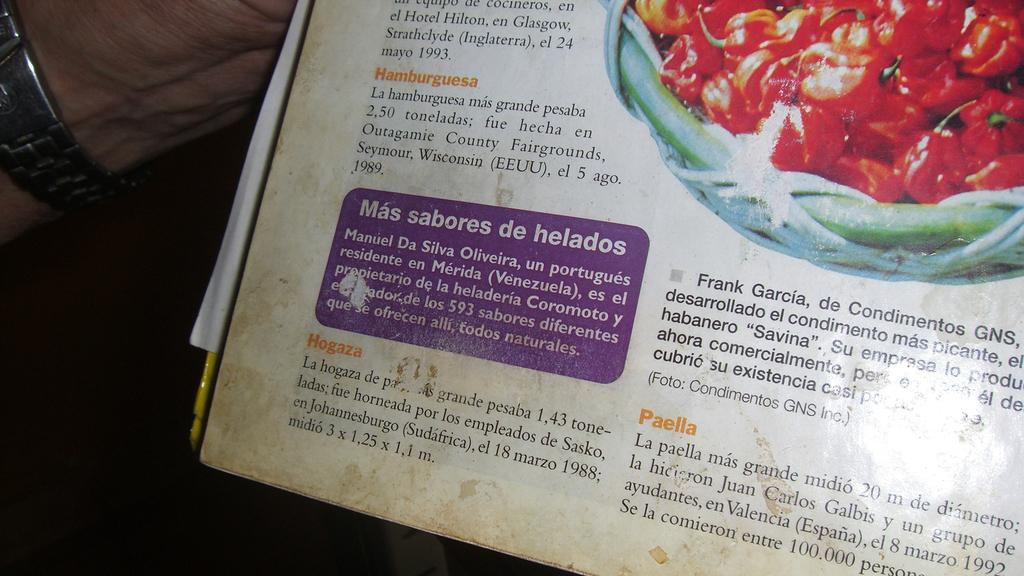<image>
Summarize the visual content of the image. A purple box on a book page says "mas sabores de helados". 